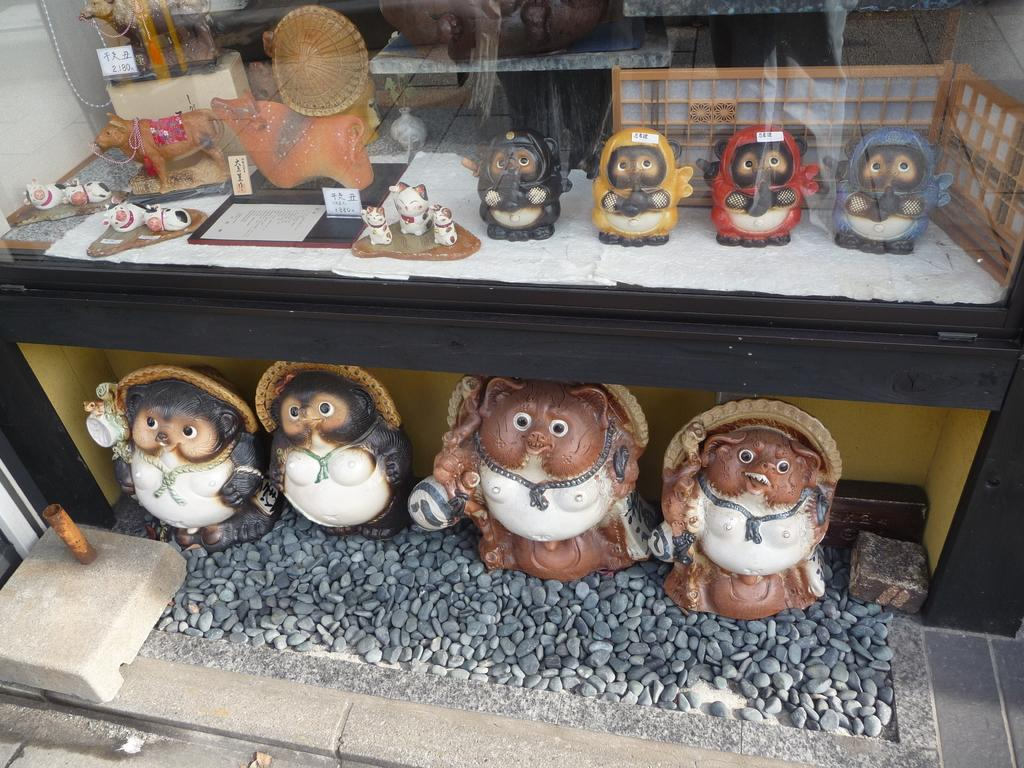What objects are placed on the pebbles in the image? There are statues on the pebbles in the image. What is the transparent object in the image? There is a glass in the image. What can be seen through the glass? Through the glass, statues, toys, cards, and paper are visible. How does the kite help the statues on the pebbles in the image? There is no kite present in the image, so it cannot help the statues on the pebbles. What is the thumb's role in the image? There is no mention of a thumb in the image, so it does not have a role in the image. 